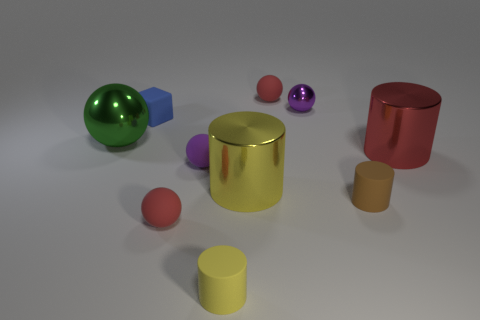How many tiny brown blocks are there?
Your response must be concise. 0. What is the color of the large metal thing on the left side of the small red matte ball that is in front of the blue block?
Your answer should be compact. Green. What color is the block that is the same size as the purple matte object?
Keep it short and to the point. Blue. Is there a object that has the same color as the small shiny ball?
Your answer should be very brief. Yes. Is there a tiny brown rubber cylinder?
Give a very brief answer. Yes. The purple thing that is in front of the red shiny object has what shape?
Make the answer very short. Sphere. What number of rubber spheres are to the right of the yellow rubber object and in front of the large green shiny sphere?
Your answer should be compact. 0. What number of other things are there of the same size as the blue rubber cube?
Offer a very short reply. 6. There is a large red shiny thing that is to the right of the small yellow object; does it have the same shape as the object to the left of the rubber block?
Make the answer very short. No. What number of things are green things or objects that are behind the small blue matte cube?
Provide a short and direct response. 3. 